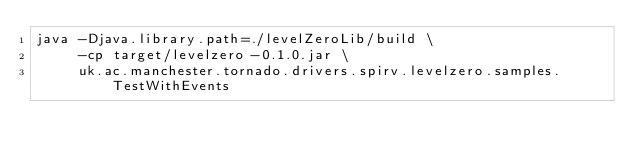Convert code to text. <code><loc_0><loc_0><loc_500><loc_500><_Bash_>java -Djava.library.path=./levelZeroLib/build \
     -cp target/levelzero-0.1.0.jar \
     uk.ac.manchester.tornado.drivers.spirv.levelzero.samples.TestWithEvents
</code> 